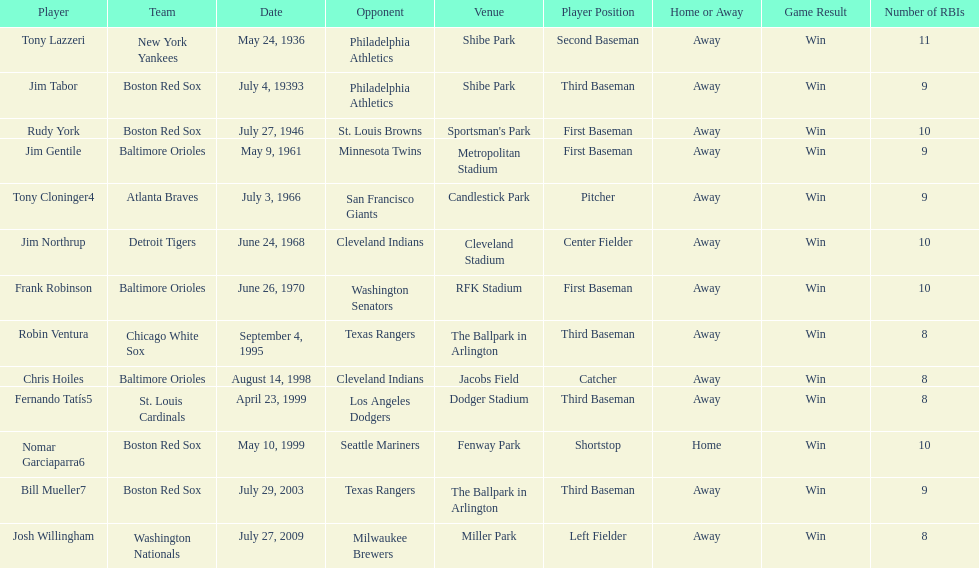Give me the full table as a dictionary. {'header': ['Player', 'Team', 'Date', 'Opponent', 'Venue', 'Player Position', 'Home or Away', 'Game Result', 'Number of RBIs'], 'rows': [['Tony Lazzeri', 'New York Yankees', 'May 24, 1936', 'Philadelphia Athletics', 'Shibe Park', 'Second Baseman', 'Away', 'Win', '11'], ['Jim Tabor', 'Boston Red Sox', 'July 4, 19393', 'Philadelphia Athletics', 'Shibe Park', 'Third Baseman', 'Away', 'Win', '9'], ['Rudy York', 'Boston Red Sox', 'July 27, 1946', 'St. Louis Browns', "Sportsman's Park", 'First Baseman', 'Away', 'Win', '10'], ['Jim Gentile', 'Baltimore Orioles', 'May 9, 1961', 'Minnesota Twins', 'Metropolitan Stadium', 'First Baseman', 'Away', 'Win', '9'], ['Tony Cloninger4', 'Atlanta Braves', 'July 3, 1966', 'San Francisco Giants', 'Candlestick Park', 'Pitcher', 'Away', 'Win', '9'], ['Jim Northrup', 'Detroit Tigers', 'June 24, 1968', 'Cleveland Indians', 'Cleveland Stadium', 'Center Fielder', 'Away', 'Win', '10'], ['Frank Robinson', 'Baltimore Orioles', 'June 26, 1970', 'Washington Senators', 'RFK Stadium', 'First Baseman', 'Away', 'Win', '10'], ['Robin Ventura', 'Chicago White Sox', 'September 4, 1995', 'Texas Rangers', 'The Ballpark in Arlington', 'Third Baseman', 'Away', 'Win', '8'], ['Chris Hoiles', 'Baltimore Orioles', 'August 14, 1998', 'Cleveland Indians', 'Jacobs Field', 'Catcher', 'Away', 'Win', '8'], ['Fernando Tatís5', 'St. Louis Cardinals', 'April 23, 1999', 'Los Angeles Dodgers', 'Dodger Stadium', 'Third Baseman', 'Away', 'Win', '8'], ['Nomar Garciaparra6', 'Boston Red Sox', 'May 10, 1999', 'Seattle Mariners', 'Fenway Park', 'Shortstop', 'Home', 'Win', '10'], ['Bill Mueller7', 'Boston Red Sox', 'July 29, 2003', 'Texas Rangers', 'The Ballpark in Arlington', 'Third Baseman', 'Away', 'Win', '9'], ['Josh Willingham', 'Washington Nationals', 'July 27, 2009', 'Milwaukee Brewers', 'Miller Park', 'Left Fielder', 'Away', 'Win', '8']]} Who was the opponent for the boston red sox on july 27, 1946? St. Louis Browns. 